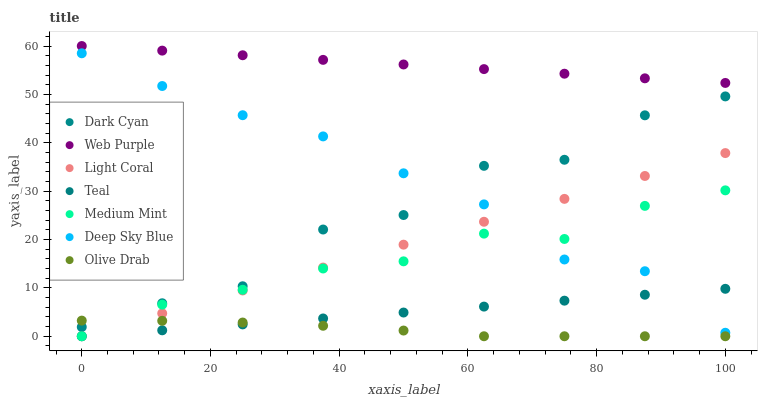Does Olive Drab have the minimum area under the curve?
Answer yes or no. Yes. Does Web Purple have the maximum area under the curve?
Answer yes or no. Yes. Does Teal have the minimum area under the curve?
Answer yes or no. No. Does Teal have the maximum area under the curve?
Answer yes or no. No. Is Web Purple the smoothest?
Answer yes or no. Yes. Is Dark Cyan the roughest?
Answer yes or no. Yes. Is Teal the smoothest?
Answer yes or no. No. Is Teal the roughest?
Answer yes or no. No. Does Medium Mint have the lowest value?
Answer yes or no. Yes. Does Web Purple have the lowest value?
Answer yes or no. No. Does Web Purple have the highest value?
Answer yes or no. Yes. Does Teal have the highest value?
Answer yes or no. No. Is Light Coral less than Web Purple?
Answer yes or no. Yes. Is Dark Cyan greater than Medium Mint?
Answer yes or no. Yes. Does Deep Sky Blue intersect Light Coral?
Answer yes or no. Yes. Is Deep Sky Blue less than Light Coral?
Answer yes or no. No. Is Deep Sky Blue greater than Light Coral?
Answer yes or no. No. Does Light Coral intersect Web Purple?
Answer yes or no. No. 